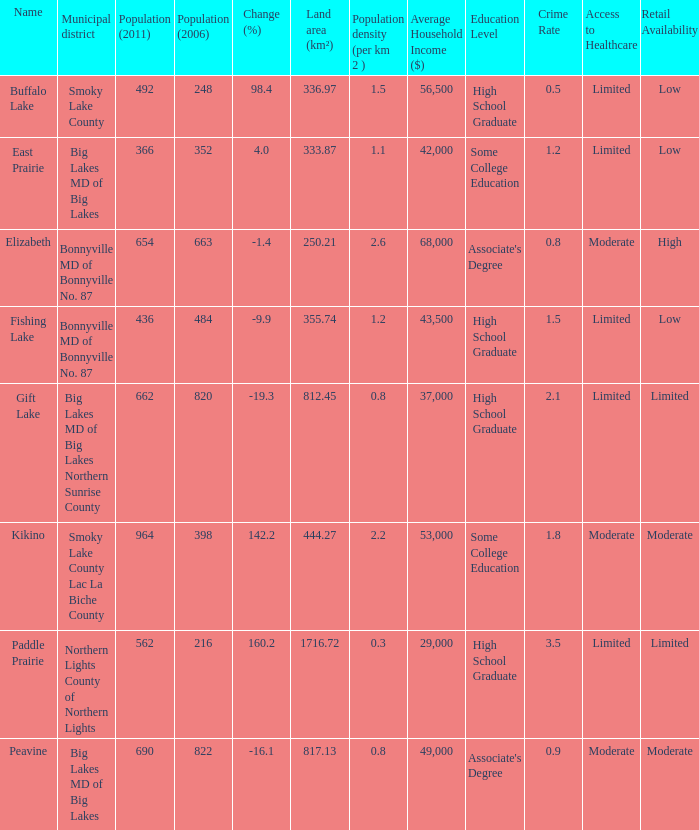What is the population per km in Smoky Lake County? 1.5. 